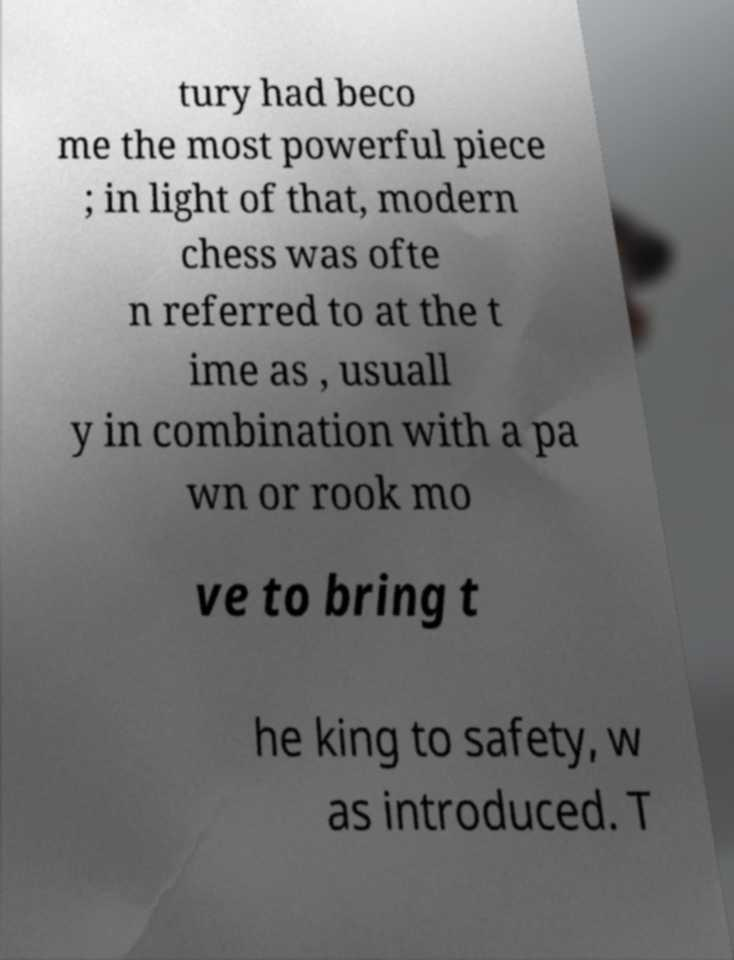Please read and relay the text visible in this image. What does it say? tury had beco me the most powerful piece ; in light of that, modern chess was ofte n referred to at the t ime as , usuall y in combination with a pa wn or rook mo ve to bring t he king to safety, w as introduced. T 